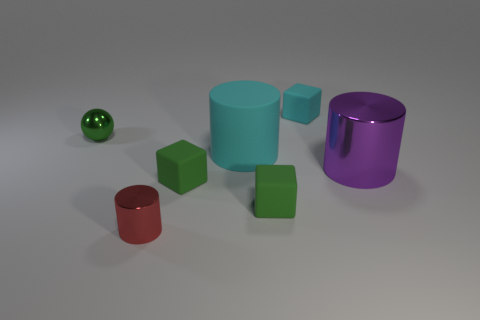Subtract all shiny cylinders. How many cylinders are left? 1 Add 2 cyan matte cylinders. How many objects exist? 9 Subtract all green spheres. How many green blocks are left? 2 Subtract all red cylinders. How many cylinders are left? 2 Subtract all balls. How many objects are left? 6 Subtract 2 cubes. How many cubes are left? 1 Subtract all cyan cylinders. Subtract all brown cubes. How many cylinders are left? 2 Subtract all large cyan cylinders. Subtract all large cyan spheres. How many objects are left? 6 Add 4 big purple things. How many big purple things are left? 5 Add 1 tiny purple cylinders. How many tiny purple cylinders exist? 1 